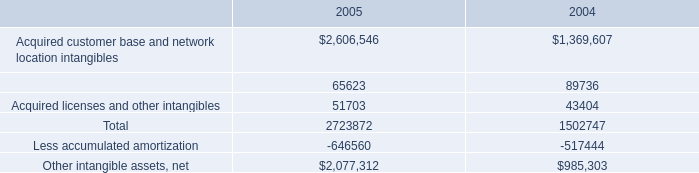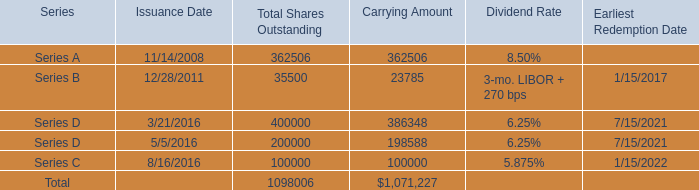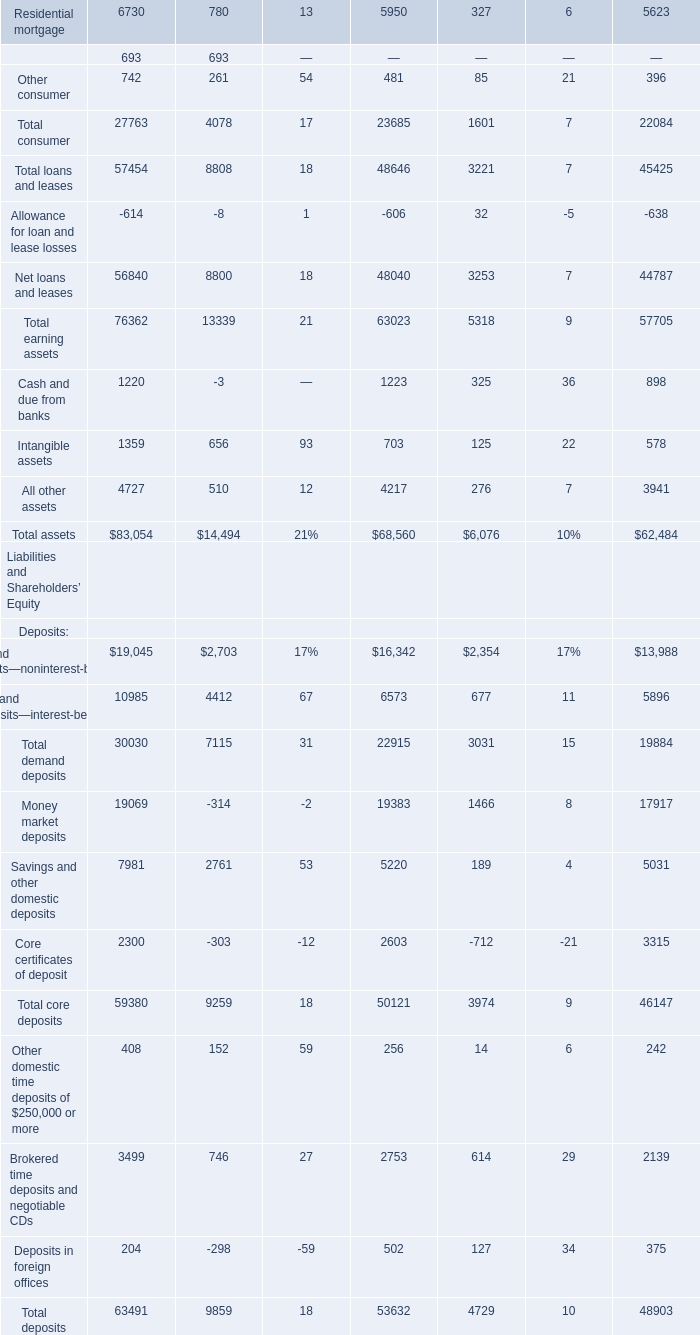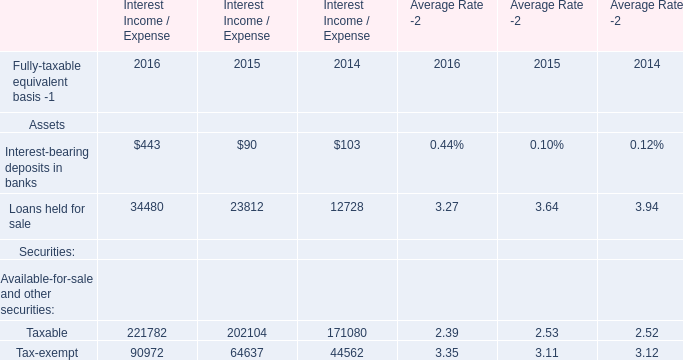What is the average amount of Acquired licenses and other intangibles of 2004, and Loans held for sale of Interest Income / Expense 2014 ? 
Computations: ((43404.0 + 12728.0) / 2)
Answer: 28066.0. 